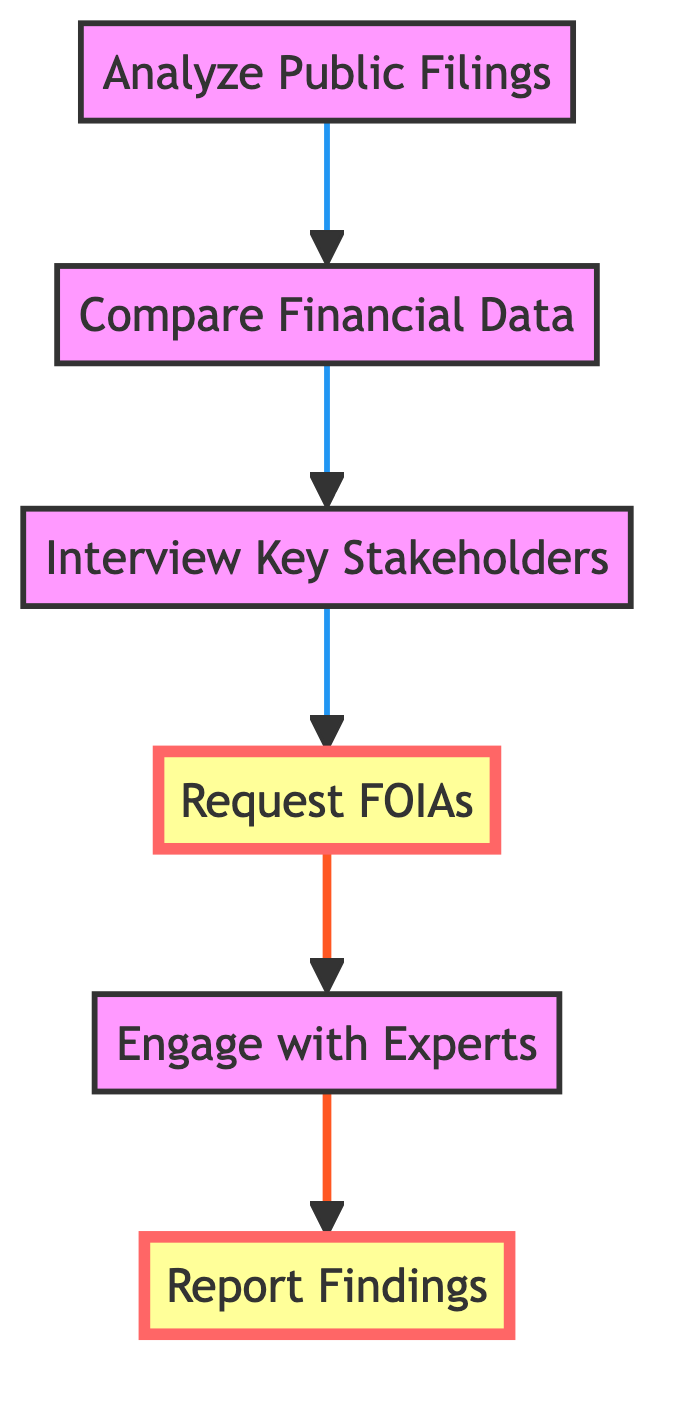What is the first step in the investigative process? The first step is indicated as "Analyze Public Filings" in the flow chart, which is the starting point for the investigation.
Answer: Analyze Public Filings How many steps are there in total in the diagram? Counting all the distinct steps, we have 6 steps listed in the flow chart.
Answer: 6 What is the last step in the process? According to the diagram, the last step is "Report Findings," which concludes the investigative process.
Answer: Report Findings Which step comes directly before "Request FOIAs"? The step that comes right before "Request FOIAs" is "Interview Key Stakeholders," showing the flow of the investigative process.
Answer: Interview Key Stakeholders What is the significance of the colored nodes in the diagram? The highlighted nodes indicate the steps that may require special attention; in this case, "Request FOIAs" and "Report Findings" stand out for their importance in the process.
Answer: They indicate special attention Which step involves consulting with professionals? The step that includes consulting with professionals is "Engage with Experts," where financial experts and auditors are involved.
Answer: Engage with Experts What type of requests are filed in the fourth step? The fourth step involves filing "Freedom of Information Act" requests, which pertain to obtaining additional financial documents.
Answer: Freedom of Information Act What is the main focus of the "Analyze Public Filings" step? This step centers on analyzing publicly available financial records and reports from independent schools, emphasizing scrutiny of financial documentation.
Answer: Analyzing financial records Which step involves discrepancies in financial data? "Compare Financial Data" is the step dedicated to identifying discrepancies, patterns, or anomalies in the financial records of independent schools.
Answer: Compare Financial Data 